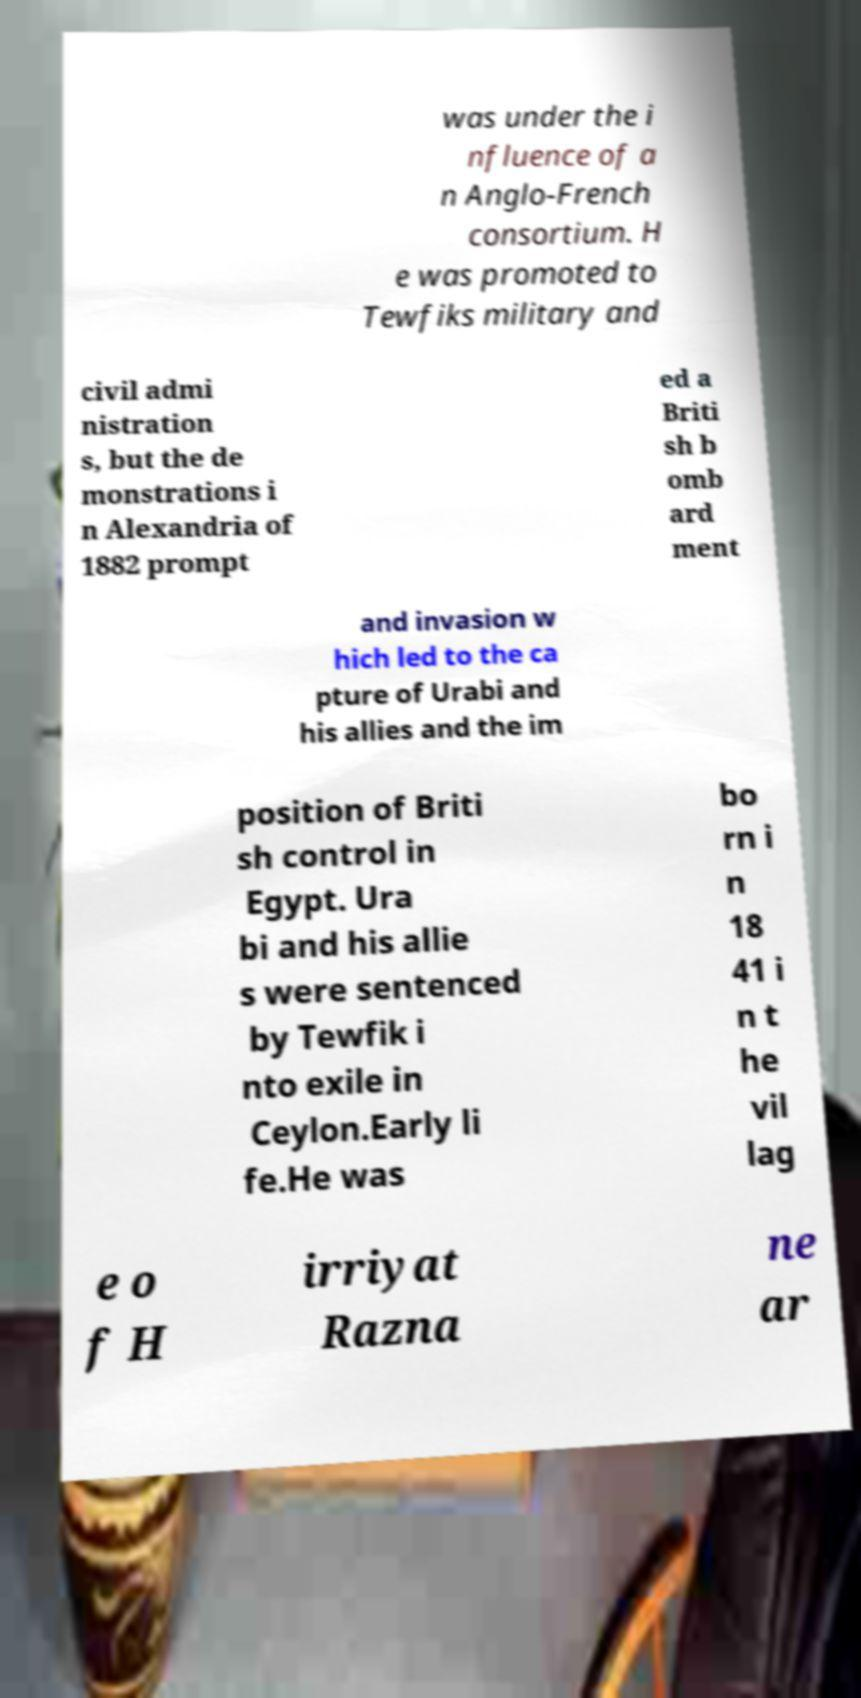Can you read and provide the text displayed in the image?This photo seems to have some interesting text. Can you extract and type it out for me? was under the i nfluence of a n Anglo-French consortium. H e was promoted to Tewfiks military and civil admi nistration s, but the de monstrations i n Alexandria of 1882 prompt ed a Briti sh b omb ard ment and invasion w hich led to the ca pture of Urabi and his allies and the im position of Briti sh control in Egypt. Ura bi and his allie s were sentenced by Tewfik i nto exile in Ceylon.Early li fe.He was bo rn i n 18 41 i n t he vil lag e o f H irriyat Razna ne ar 